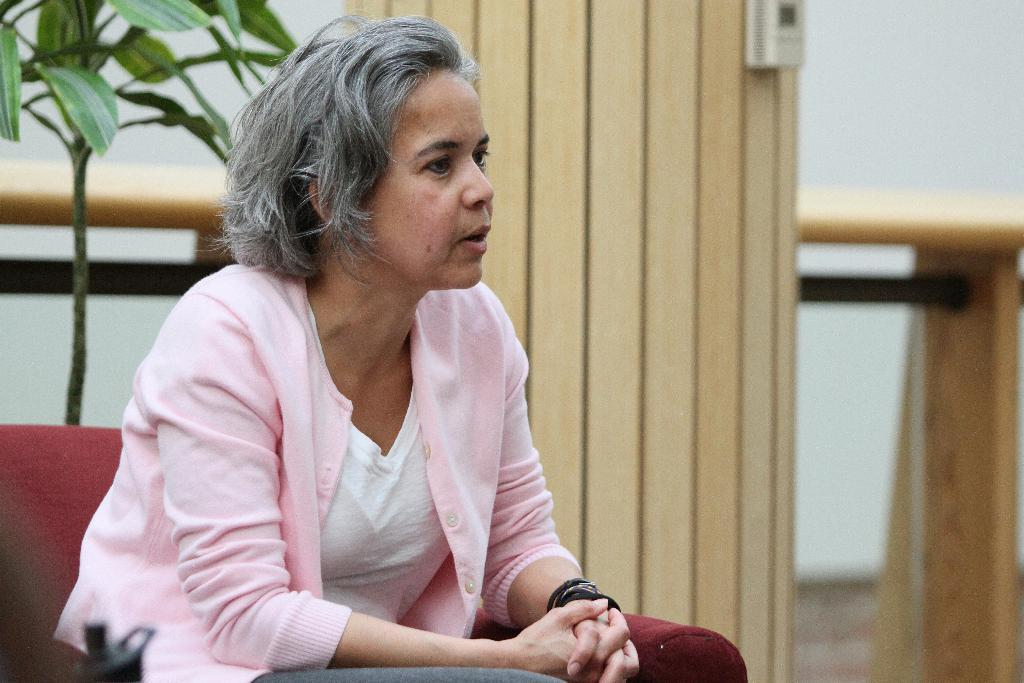What is the woman doing in the image? The woman is sitting on a couch in the image. What type of clothing is the woman wearing? The woman is wearing a jacket, a T-shirt, and trousers. What can be seen in the background of the image? There is a houseplant, a wooden board, and a table in the image. What flavor of work does the woman seem to be engaged in while sitting on the couch? The image does not depict any work or mention any flavors, so this question cannot be answered definitively. 